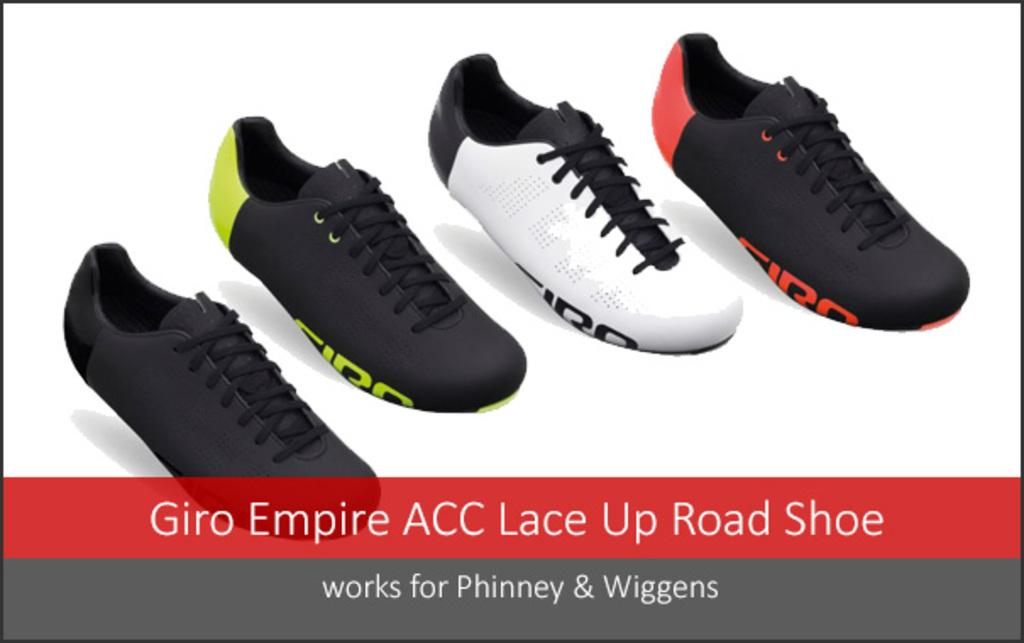How many shoes are visible in the image? There are four shoes in the image. What colors are the shoes? The shoes are in black, green, white, and red colors. What is the color of the background in the image? The background of the image is white. How many babies are sleeping in the crib in the image? There is no crib or babies present in the image; it features four shoes in different colors. 